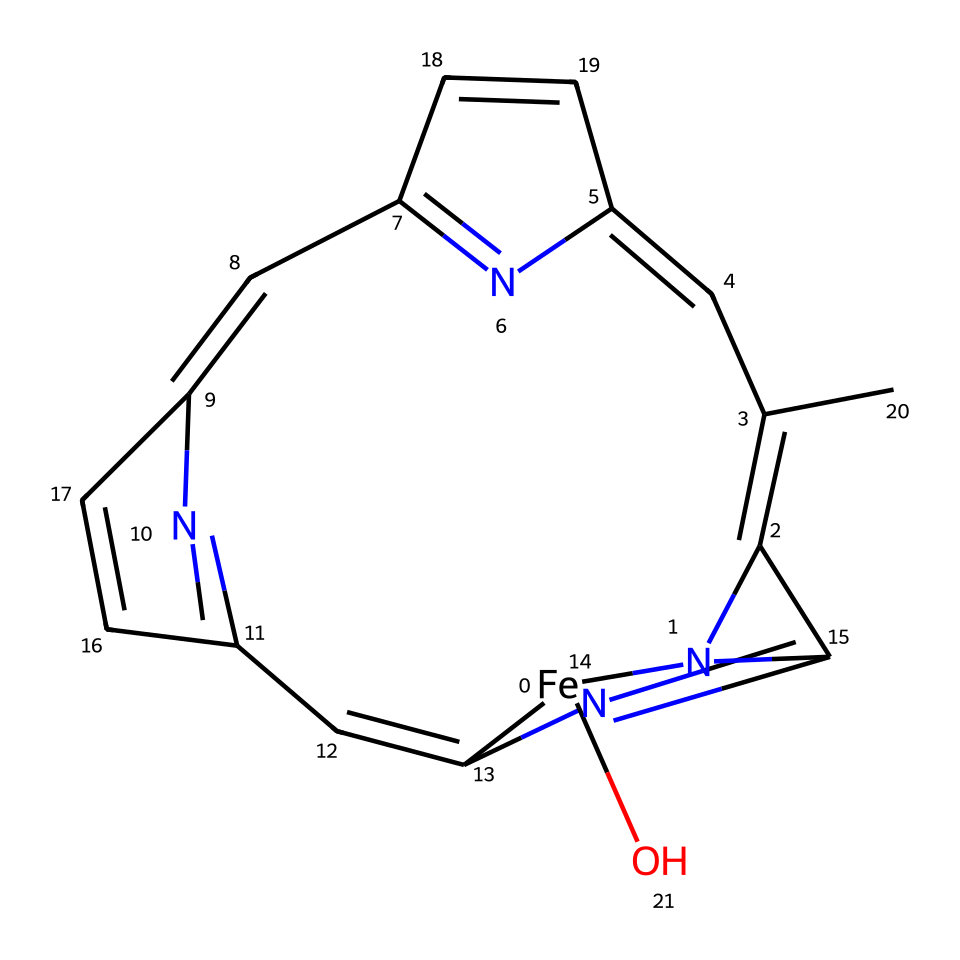What is the central metal atom in this coordination complex? The chemical structure contains an iron atom ([Fe]), which is commonly known to serve as the central metal in hemoglobin's coordination complex.
Answer: iron How many nitrogen atoms are present in the SMILES representation? By examining the SMILES representation, we can count the nitrogen atoms represented by 'N'. There are five 'N' symbols in the structure, indicating five nitrogen atoms.
Answer: 5 What type of bonding occurs between the iron and nitrogen atoms? In coordination compounds like hemoglobin, the bonding involves coordinate covalent bonds, where the nitrogen atoms donate electron pairs to the iron, allowing the formation of stable complexes.
Answer: coordinate covalent bonds What can this complex's structure suggest about its functionality? The presence of multiple nitrogen ligands coordinated to iron indicates that this complex can readily bind to oxygen molecules, a critical function necessary for transport in biological systems like hemoglobin.
Answer: oxygen transport What type of coordination geometry does this complex exhibit? Based on the arrangement of the ligands around the iron atom, one can deduce that the coordination geometry is octahedral due to the number of ligands typically found around a central metal in such complexes.
Answer: octahedral What is the significance of the cyclic nature of the structure? The cyclic components within the structure suggest that interactions among the ligands can introduce stability and are characteristic of the planar ring structure seen in heme groups, contributing to the overall functionality of the protein.
Answer: stability 